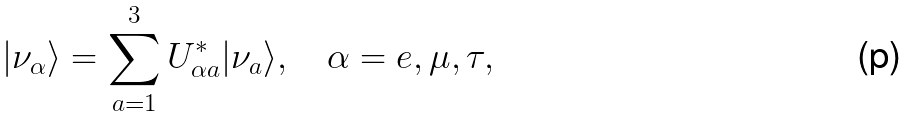<formula> <loc_0><loc_0><loc_500><loc_500>| \nu _ { \alpha } \rangle = \sum _ { a = 1 } ^ { 3 } U ^ { \ast } _ { \alpha a } | \nu _ { a } \rangle , \quad \alpha = e , \mu , \tau ,</formula> 